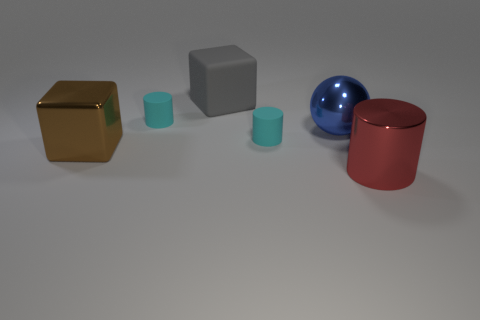Subtract all green cylinders. Subtract all yellow balls. How many cylinders are left? 3 Add 1 big red rubber blocks. How many objects exist? 7 Subtract all balls. How many objects are left? 5 Add 3 big red metallic objects. How many big red metallic objects are left? 4 Add 1 large blue objects. How many large blue objects exist? 2 Subtract 1 gray blocks. How many objects are left? 5 Subtract all tiny rubber objects. Subtract all red metal things. How many objects are left? 3 